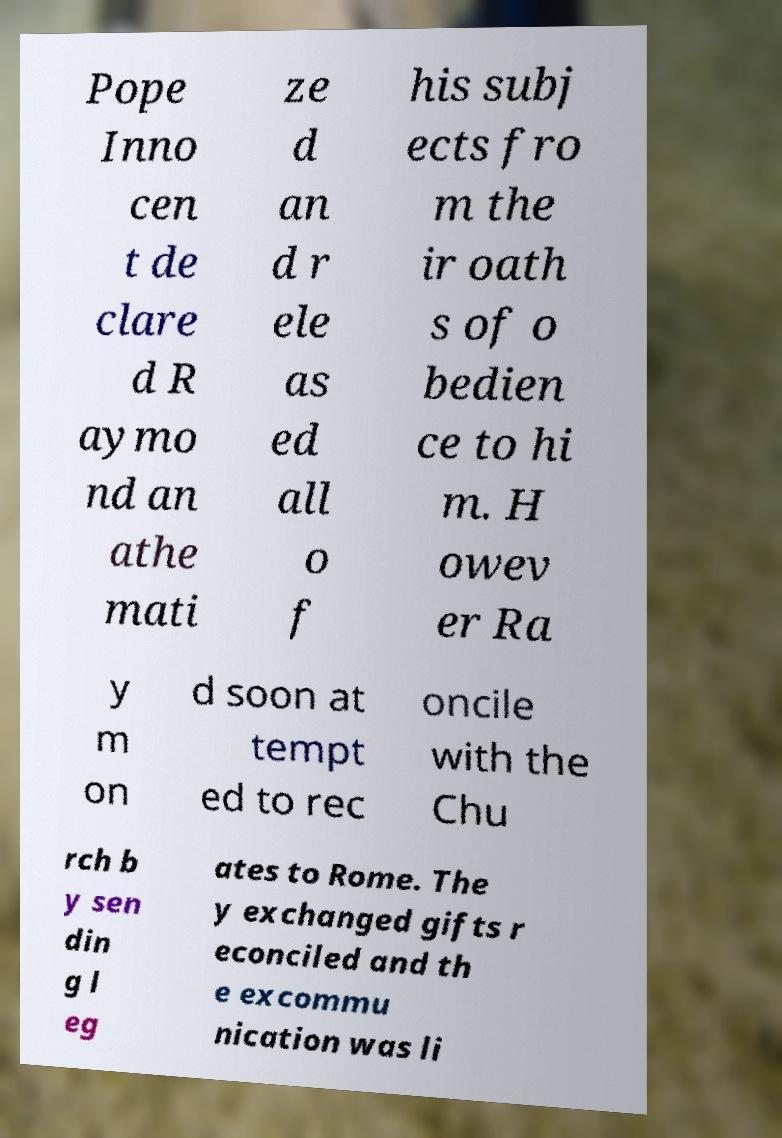What messages or text are displayed in this image? I need them in a readable, typed format. Pope Inno cen t de clare d R aymo nd an athe mati ze d an d r ele as ed all o f his subj ects fro m the ir oath s of o bedien ce to hi m. H owev er Ra y m on d soon at tempt ed to rec oncile with the Chu rch b y sen din g l eg ates to Rome. The y exchanged gifts r econciled and th e excommu nication was li 